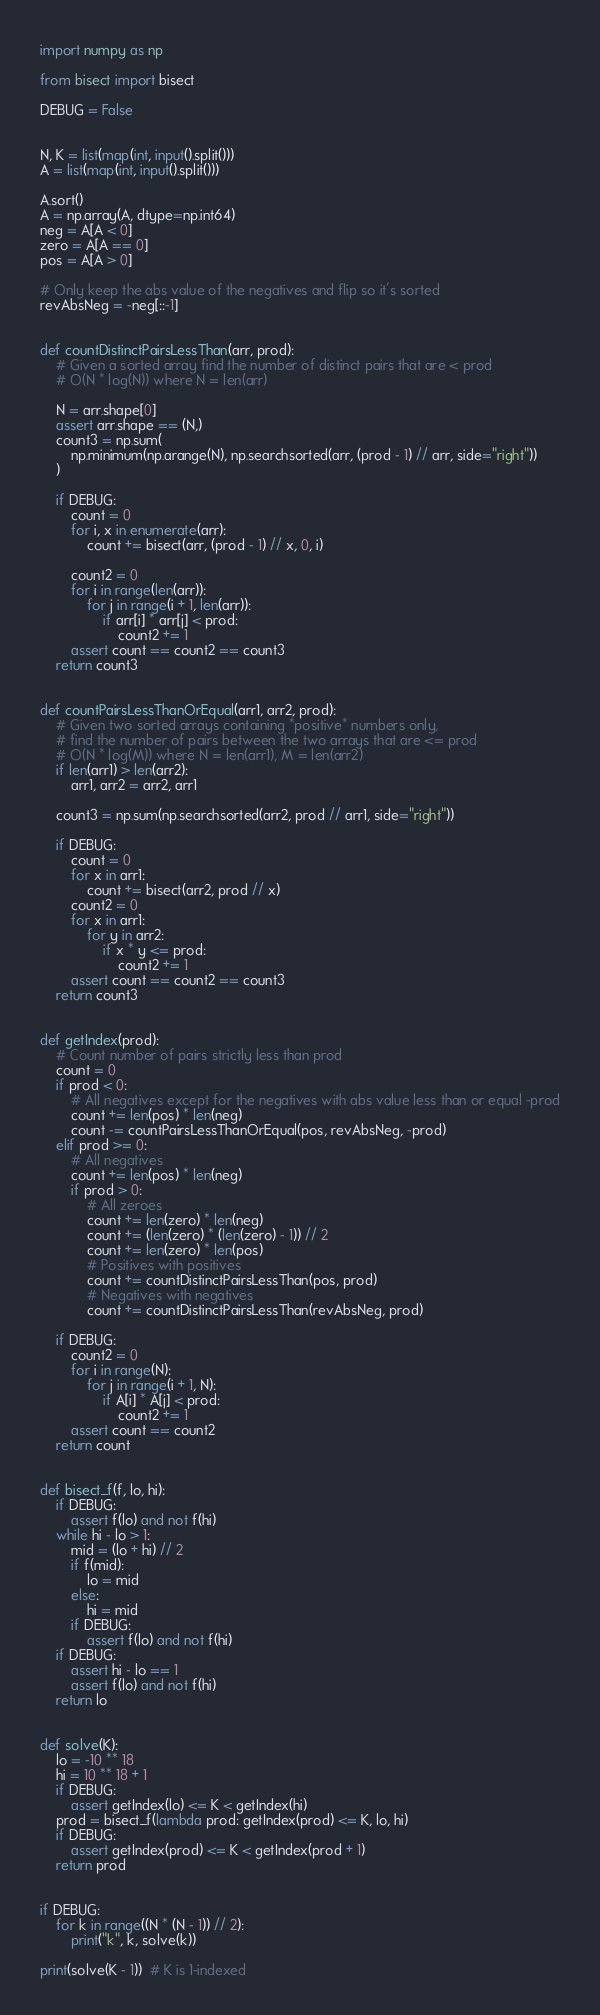<code> <loc_0><loc_0><loc_500><loc_500><_Python_>import numpy as np

from bisect import bisect

DEBUG = False


N, K = list(map(int, input().split()))
A = list(map(int, input().split()))

A.sort()
A = np.array(A, dtype=np.int64)
neg = A[A < 0]
zero = A[A == 0]
pos = A[A > 0]

# Only keep the abs value of the negatives and flip so it's sorted
revAbsNeg = -neg[::-1]


def countDistinctPairsLessThan(arr, prod):
    # Given a sorted array find the number of distinct pairs that are < prod
    # O(N * log(N)) where N = len(arr)

    N = arr.shape[0]
    assert arr.shape == (N,)
    count3 = np.sum(
        np.minimum(np.arange(N), np.searchsorted(arr, (prod - 1) // arr, side="right"))
    )

    if DEBUG:
        count = 0
        for i, x in enumerate(arr):
            count += bisect(arr, (prod - 1) // x, 0, i)

        count2 = 0
        for i in range(len(arr)):
            for j in range(i + 1, len(arr)):
                if arr[i] * arr[j] < prod:
                    count2 += 1
        assert count == count2 == count3
    return count3


def countPairsLessThanOrEqual(arr1, arr2, prod):
    # Given two sorted arrays containing *positive* numbers only,
    # find the number of pairs between the two arrays that are <= prod
    # O(N * log(M)) where N = len(arr1), M = len(arr2)
    if len(arr1) > len(arr2):
        arr1, arr2 = arr2, arr1

    count3 = np.sum(np.searchsorted(arr2, prod // arr1, side="right"))

    if DEBUG:
        count = 0
        for x in arr1:
            count += bisect(arr2, prod // x)
        count2 = 0
        for x in arr1:
            for y in arr2:
                if x * y <= prod:
                    count2 += 1
        assert count == count2 == count3
    return count3


def getIndex(prod):
    # Count number of pairs strictly less than prod
    count = 0
    if prod < 0:
        # All negatives except for the negatives with abs value less than or equal -prod
        count += len(pos) * len(neg)
        count -= countPairsLessThanOrEqual(pos, revAbsNeg, -prod)
    elif prod >= 0:
        # All negatives
        count += len(pos) * len(neg)
        if prod > 0:
            # All zeroes
            count += len(zero) * len(neg)
            count += (len(zero) * (len(zero) - 1)) // 2
            count += len(zero) * len(pos)
            # Positives with positives
            count += countDistinctPairsLessThan(pos, prod)
            # Negatives with negatives
            count += countDistinctPairsLessThan(revAbsNeg, prod)

    if DEBUG:
        count2 = 0
        for i in range(N):
            for j in range(i + 1, N):
                if A[i] * A[j] < prod:
                    count2 += 1
        assert count == count2
    return count


def bisect_f(f, lo, hi):
    if DEBUG:
        assert f(lo) and not f(hi)
    while hi - lo > 1:
        mid = (lo + hi) // 2
        if f(mid):
            lo = mid
        else:
            hi = mid
        if DEBUG:
            assert f(lo) and not f(hi)
    if DEBUG:
        assert hi - lo == 1
        assert f(lo) and not f(hi)
    return lo


def solve(K):
    lo = -10 ** 18
    hi = 10 ** 18 + 1
    if DEBUG:
        assert getIndex(lo) <= K < getIndex(hi)
    prod = bisect_f(lambda prod: getIndex(prod) <= K, lo, hi)
    if DEBUG:
        assert getIndex(prod) <= K < getIndex(prod + 1)
    return prod


if DEBUG:
    for k in range((N * (N - 1)) // 2):
        print("k", k, solve(k))

print(solve(K - 1))  # K is 1-indexed
</code> 